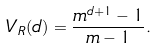Convert formula to latex. <formula><loc_0><loc_0><loc_500><loc_500>V _ { R } ( d ) & = \frac { m ^ { d + 1 } - 1 } { m - 1 } .</formula> 